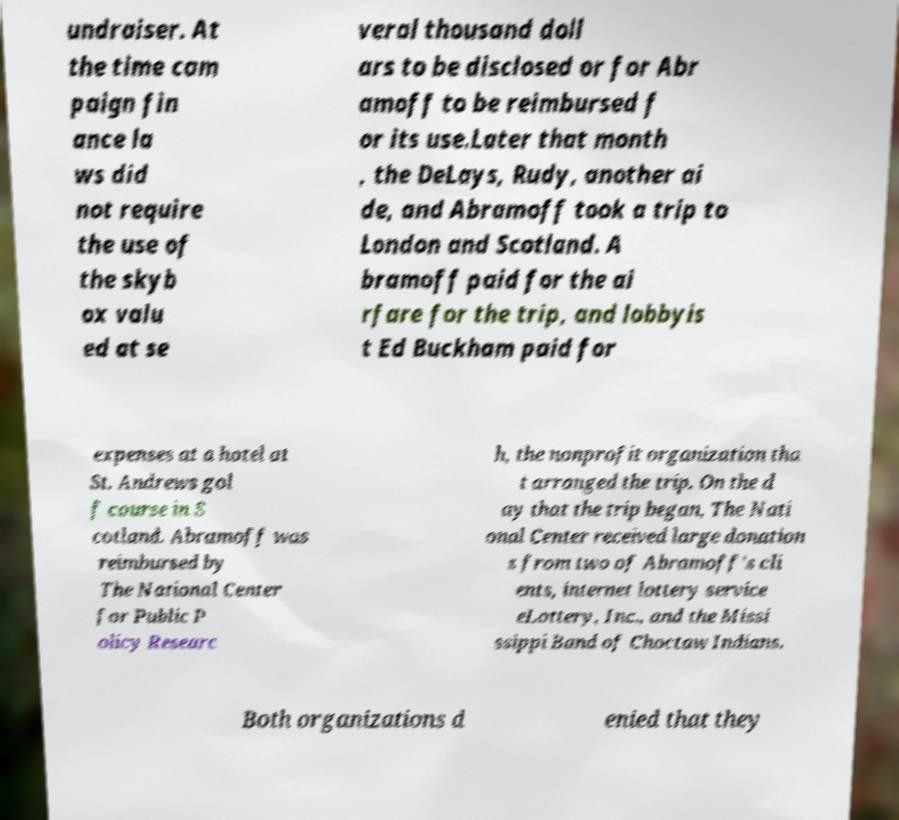Could you extract and type out the text from this image? undraiser. At the time cam paign fin ance la ws did not require the use of the skyb ox valu ed at se veral thousand doll ars to be disclosed or for Abr amoff to be reimbursed f or its use.Later that month , the DeLays, Rudy, another ai de, and Abramoff took a trip to London and Scotland. A bramoff paid for the ai rfare for the trip, and lobbyis t Ed Buckham paid for expenses at a hotel at St. Andrews gol f course in S cotland. Abramoff was reimbursed by The National Center for Public P olicy Researc h, the nonprofit organization tha t arranged the trip. On the d ay that the trip began, The Nati onal Center received large donation s from two of Abramoff's cli ents, internet lottery service eLottery, Inc., and the Missi ssippi Band of Choctaw Indians. Both organizations d enied that they 